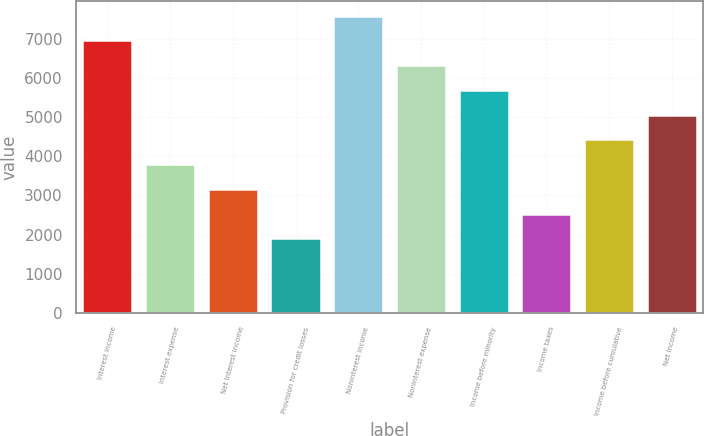Convert chart. <chart><loc_0><loc_0><loc_500><loc_500><bar_chart><fcel>Interest income<fcel>Interest expense<fcel>Net interest income<fcel>Provision for credit losses<fcel>Noninterest income<fcel>Noninterest expense<fcel>Income before minority<fcel>Income taxes<fcel>Income before cumulative<fcel>Net income<nl><fcel>6959.51<fcel>3797.08<fcel>3164.59<fcel>1899.61<fcel>7592<fcel>6327.03<fcel>5694.55<fcel>2532.1<fcel>4429.57<fcel>5062.06<nl></chart> 